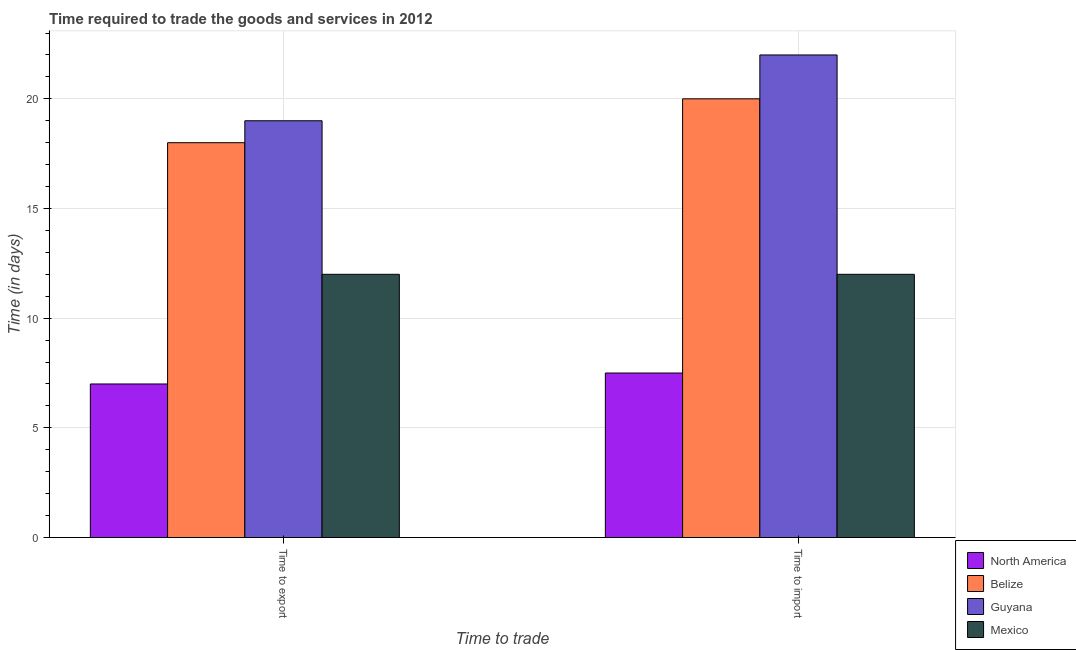How many groups of bars are there?
Make the answer very short. 2. How many bars are there on the 1st tick from the left?
Ensure brevity in your answer.  4. How many bars are there on the 2nd tick from the right?
Make the answer very short. 4. What is the label of the 2nd group of bars from the left?
Make the answer very short. Time to import. What is the time to export in North America?
Offer a very short reply. 7. Across all countries, what is the minimum time to import?
Keep it short and to the point. 7.5. In which country was the time to export maximum?
Give a very brief answer. Guyana. In which country was the time to import minimum?
Make the answer very short. North America. What is the total time to export in the graph?
Offer a very short reply. 56. What is the difference between the time to export in Guyana and the time to import in Belize?
Provide a succinct answer. -1. What is the average time to import per country?
Provide a succinct answer. 15.38. What is the difference between the time to import and time to export in Mexico?
Make the answer very short. 0. What is the ratio of the time to import in Belize to that in North America?
Make the answer very short. 2.67. What does the 2nd bar from the left in Time to import represents?
Your answer should be very brief. Belize. What does the 2nd bar from the right in Time to import represents?
Your answer should be very brief. Guyana. How many bars are there?
Keep it short and to the point. 8. Does the graph contain any zero values?
Make the answer very short. No. Does the graph contain grids?
Your answer should be compact. Yes. Where does the legend appear in the graph?
Offer a terse response. Bottom right. How are the legend labels stacked?
Provide a succinct answer. Vertical. What is the title of the graph?
Your answer should be compact. Time required to trade the goods and services in 2012. Does "San Marino" appear as one of the legend labels in the graph?
Make the answer very short. No. What is the label or title of the X-axis?
Offer a very short reply. Time to trade. What is the label or title of the Y-axis?
Your answer should be compact. Time (in days). What is the Time (in days) of Belize in Time to export?
Offer a very short reply. 18. What is the Time (in days) of Guyana in Time to export?
Make the answer very short. 19. What is the Time (in days) of North America in Time to import?
Give a very brief answer. 7.5. What is the Time (in days) of Guyana in Time to import?
Offer a terse response. 22. What is the Time (in days) of Mexico in Time to import?
Provide a short and direct response. 12. Across all Time to trade, what is the maximum Time (in days) in Belize?
Give a very brief answer. 20. Across all Time to trade, what is the maximum Time (in days) in Guyana?
Offer a very short reply. 22. Across all Time to trade, what is the minimum Time (in days) in North America?
Your answer should be compact. 7. Across all Time to trade, what is the minimum Time (in days) of Belize?
Offer a terse response. 18. Across all Time to trade, what is the minimum Time (in days) of Guyana?
Your response must be concise. 19. What is the total Time (in days) of Belize in the graph?
Ensure brevity in your answer.  38. What is the total Time (in days) in Guyana in the graph?
Provide a short and direct response. 41. What is the difference between the Time (in days) in Belize in Time to export and that in Time to import?
Provide a short and direct response. -2. What is the difference between the Time (in days) of Guyana in Time to export and that in Time to import?
Ensure brevity in your answer.  -3. What is the difference between the Time (in days) of North America in Time to export and the Time (in days) of Guyana in Time to import?
Provide a succinct answer. -15. What is the difference between the Time (in days) in Belize in Time to export and the Time (in days) in Guyana in Time to import?
Give a very brief answer. -4. What is the difference between the Time (in days) of Guyana in Time to export and the Time (in days) of Mexico in Time to import?
Give a very brief answer. 7. What is the average Time (in days) of North America per Time to trade?
Provide a succinct answer. 7.25. What is the average Time (in days) in Belize per Time to trade?
Your answer should be very brief. 19. What is the average Time (in days) in Mexico per Time to trade?
Ensure brevity in your answer.  12. What is the difference between the Time (in days) of North America and Time (in days) of Guyana in Time to export?
Make the answer very short. -12. What is the difference between the Time (in days) in North America and Time (in days) in Mexico in Time to export?
Give a very brief answer. -5. What is the difference between the Time (in days) in Belize and Time (in days) in Guyana in Time to export?
Offer a very short reply. -1. What is the difference between the Time (in days) in Guyana and Time (in days) in Mexico in Time to export?
Provide a short and direct response. 7. What is the difference between the Time (in days) in North America and Time (in days) in Guyana in Time to import?
Your answer should be very brief. -14.5. What is the difference between the Time (in days) in North America and Time (in days) in Mexico in Time to import?
Provide a succinct answer. -4.5. What is the difference between the Time (in days) in Belize and Time (in days) in Guyana in Time to import?
Your answer should be compact. -2. What is the difference between the Time (in days) in Guyana and Time (in days) in Mexico in Time to import?
Ensure brevity in your answer.  10. What is the ratio of the Time (in days) in Guyana in Time to export to that in Time to import?
Offer a terse response. 0.86. What is the ratio of the Time (in days) of Mexico in Time to export to that in Time to import?
Keep it short and to the point. 1. What is the difference between the highest and the second highest Time (in days) of Guyana?
Provide a succinct answer. 3. What is the difference between the highest and the second highest Time (in days) of Mexico?
Provide a short and direct response. 0. What is the difference between the highest and the lowest Time (in days) in Guyana?
Offer a very short reply. 3. 